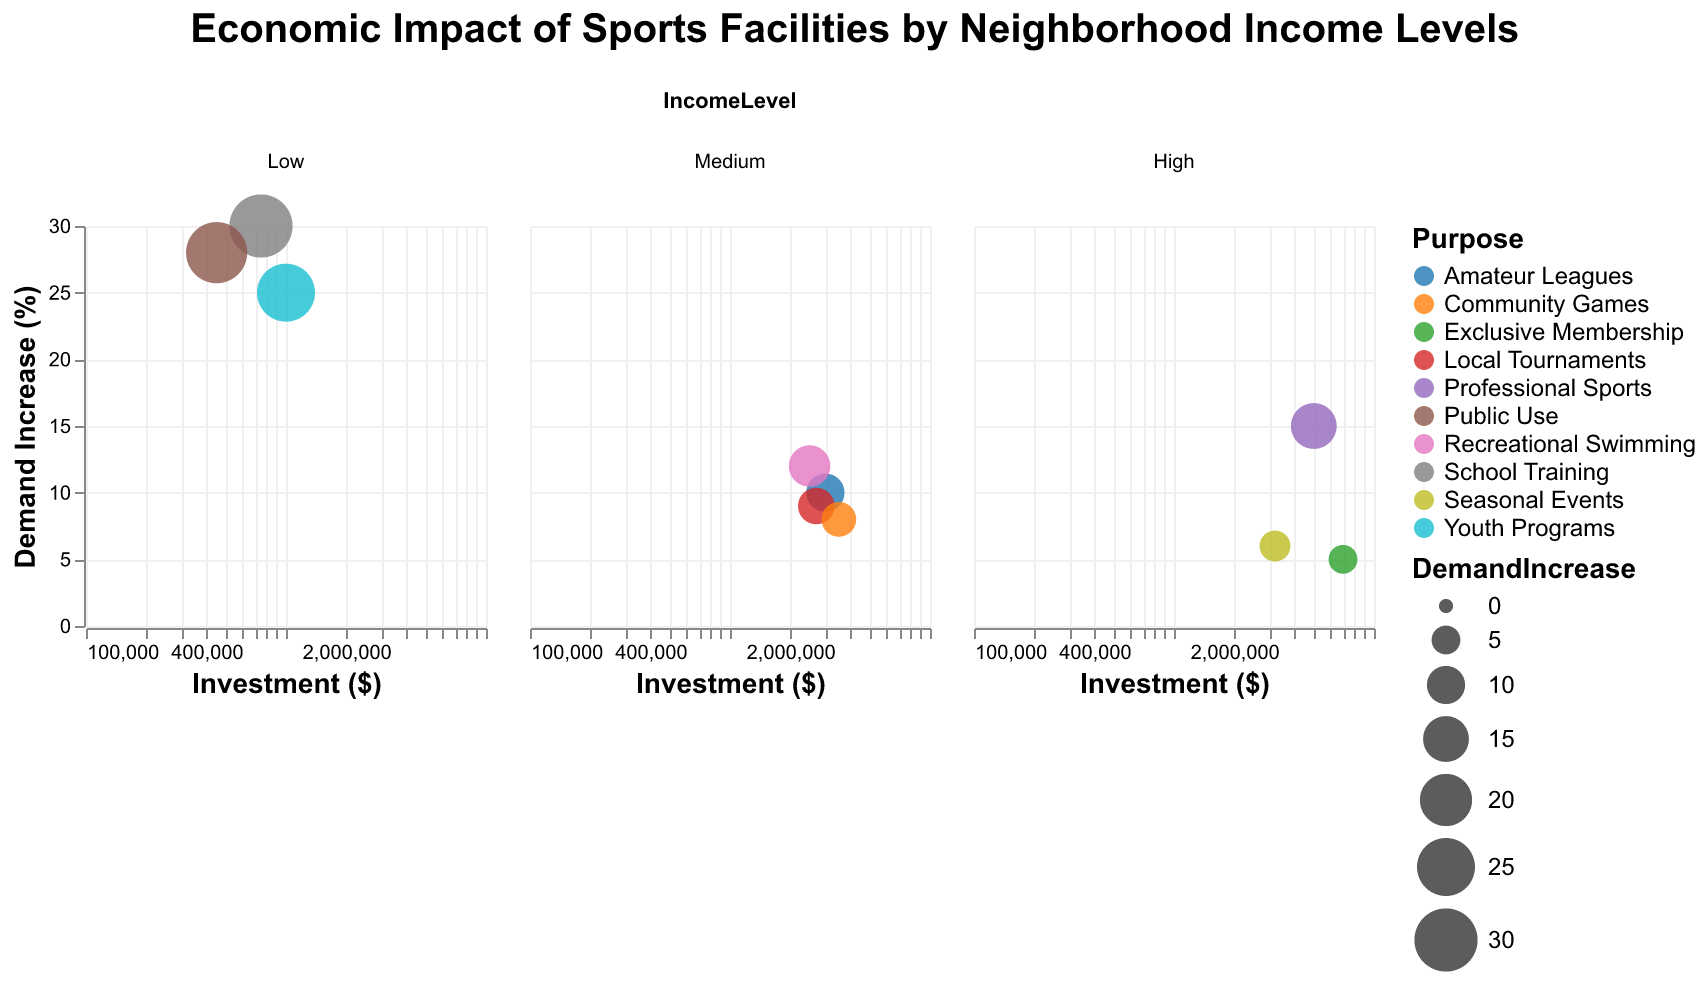What is the title of the figure? The title of the figure is usually placed at the top center of the chart. It is typically the largest text element to clearly indicate the subject of the visualization.
Answer: Economic Impact of Sports Facilities by Neighborhood Income Levels Which Neighborhood has the highest investment in a sports facility? To determine the neighborhood with the highest investment, look for the circle that is furthest to the right in terms of the x-axis (Investment). The "Golf Course" in the "Highland" neighborhood is the facility with the highest investment, marked as 7,000,000.
Answer: Highland How many types of facilities are there? The types of facilities are represented by different circles in varying colors. By counting the unique facility types mentioned in the tooltip for each bubble, we see Stadium, Community Center, Multi-sport Complex, Football Field, Golf Course, Aquatic Center, Basketball Courts, Tennis Complex, Ice Rink, and Baseball Stadium, making a total of 10 types.
Answer: 10 Which neighborhood with low income has the highest demand increase (%)? Look at the subplot corresponding to "Low" income level. Then identify the circle with the highest position on the y-axis (Demand Increase %). "Riverside" has the highest demand increase at 30%.
Answer: Riverside What is the purpose of the facility with the highest investment among Medium-income neighborhoods? First, identify the subplot for Medium income neighborhoods. Then find the bubble with the highest x-axis value (Investment). The "Baseball Stadium" in "Northview" has the highest investment of 3,500,000. According to the tooltip, its purpose is "Community Games".
Answer: Community Games Among the High-income neighborhoods, which facility has the lowest demand increase (%)? Look at the subplot for "High" income neighborhoods. Find the circle positioned lowest on the y-axis (Demand Increase %). "Golf Course" in "Highland" has the lowest demand increase of 5%.
Answer: Highland What is the average demand increase for all the facilities in Medium-income neighborhoods? Identify all the circles within the Medium-income subplot and note their Demand Increase percentages. The values are 10, 12, 9, and 8. Calculate the average: (10 + 12 + 9 + 8)/4 = 39/4 = 9.75.
Answer: 9.75% Which facility type has the largest size bubble in the Low-income subplot? Each bubble size corresponds to its Demand Increase %. In the Low-income subplot, the largest bubble is the one representing the "Football Field" in "Riverside" with a demand increase of 30%.
Answer: Football Field Is there a clear trend between income level and investment in sports facilities based on the subplot layout? Observation of the subplots for Low, Medium, and High income levels shows a possible trend. High-income neighborhoods tend to have the highest investments, visible from larger x-axis values mostly grouped to the right in the subplot. Medium-income neighborhoods have moderate investment levels, and Low-income neighborhoods have the lowest investments mostly grouped to the left.
Answer: Yes Which facility purpose is represented by the most colors? Examine the colors of the circles, each representing a different facility purpose. Count how many distinct colors there are for each purpose indicated in the color legend. Purposes might overlap but primarily, "Public Use" and "Youth Programs" among others are variously colored.
Answer: Youth Programs 